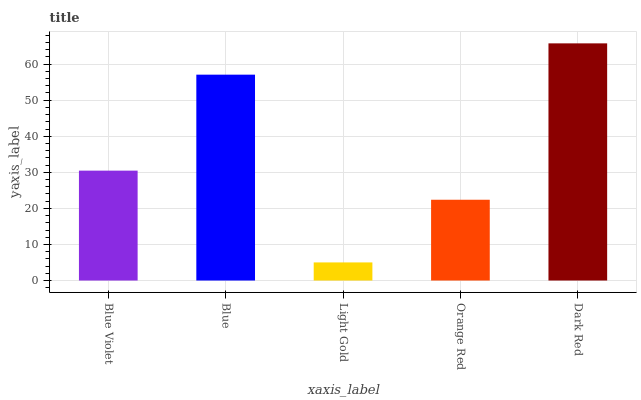Is Light Gold the minimum?
Answer yes or no. Yes. Is Dark Red the maximum?
Answer yes or no. Yes. Is Blue the minimum?
Answer yes or no. No. Is Blue the maximum?
Answer yes or no. No. Is Blue greater than Blue Violet?
Answer yes or no. Yes. Is Blue Violet less than Blue?
Answer yes or no. Yes. Is Blue Violet greater than Blue?
Answer yes or no. No. Is Blue less than Blue Violet?
Answer yes or no. No. Is Blue Violet the high median?
Answer yes or no. Yes. Is Blue Violet the low median?
Answer yes or no. Yes. Is Light Gold the high median?
Answer yes or no. No. Is Blue the low median?
Answer yes or no. No. 